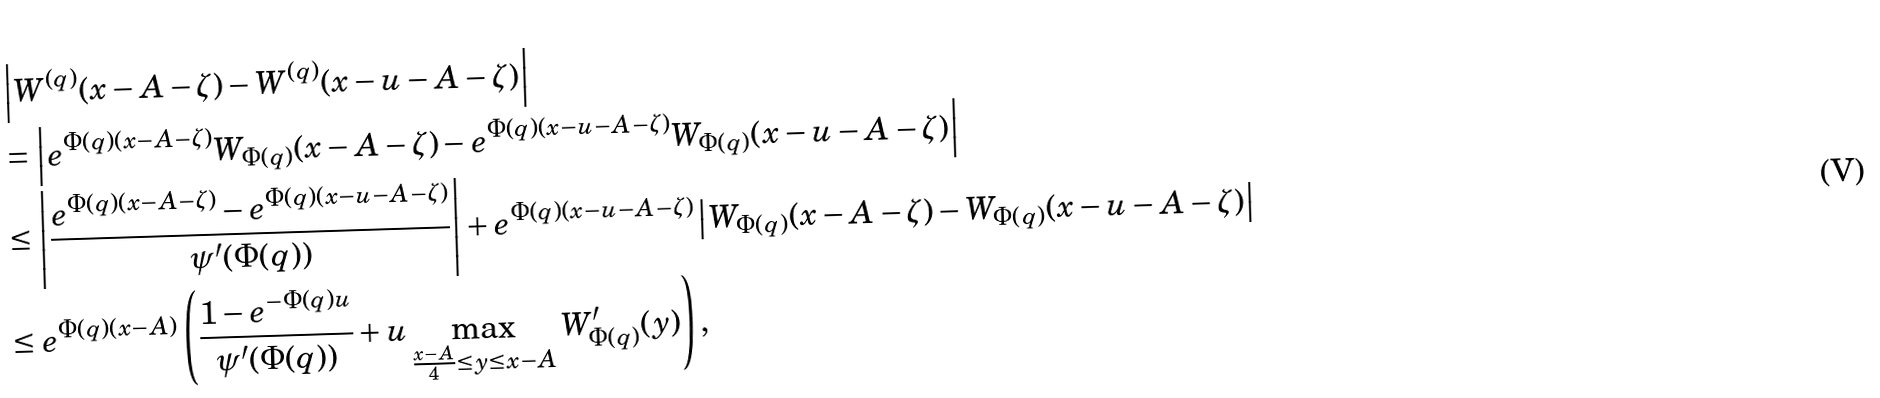Convert formula to latex. <formula><loc_0><loc_0><loc_500><loc_500>& \left | W ^ { ( q ) } ( x - A - \zeta ) - W ^ { ( q ) } ( x - u - A - \zeta ) \right | \\ & = \left | e ^ { \Phi ( q ) ( x - A - \zeta ) } W _ { \Phi ( q ) } ( x - A - \zeta ) - e ^ { \Phi ( q ) ( x - u - A - \zeta ) } W _ { \Phi ( q ) } ( x - u - A - \zeta ) \right | \\ & \leq \left | \frac { e ^ { \Phi ( q ) ( x - A - \zeta ) } - e ^ { \Phi ( q ) ( x - u - A - \zeta ) } } { \psi ^ { \prime } ( \Phi ( q ) ) } \right | + e ^ { \Phi ( q ) ( x - u - A - \zeta ) } \left | W _ { \Phi ( q ) } ( x - A - \zeta ) - W _ { \Phi ( q ) } ( x - u - A - \zeta ) \right | \\ & \leq e ^ { \Phi ( q ) ( x - A ) } \left ( \frac { 1 - e ^ { - \Phi ( q ) u } } { \psi ^ { \prime } ( \Phi ( q ) ) } + u \max _ { \frac { x - A } 4 \leq y \leq x - A } W _ { \Phi ( q ) } ^ { \prime } ( y ) \right ) ,</formula> 